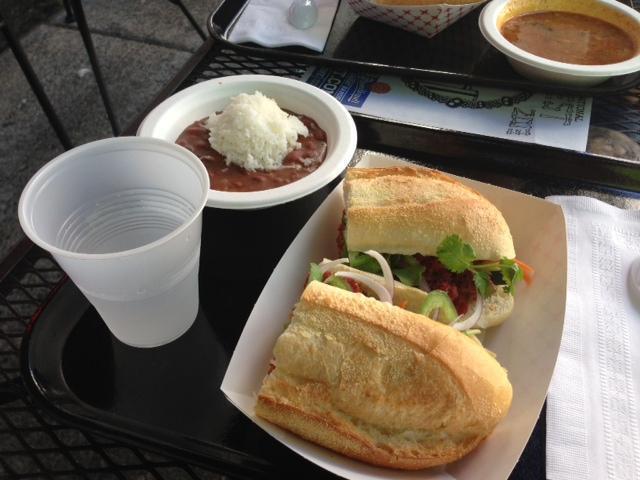How many trays of food are there?
Give a very brief answer. 2. How many cups of drinks are there?
Give a very brief answer. 1. How many sandwiches are there?
Give a very brief answer. 2. How many bowls are in the photo?
Give a very brief answer. 4. How many clocks are on the tower?
Give a very brief answer. 0. 